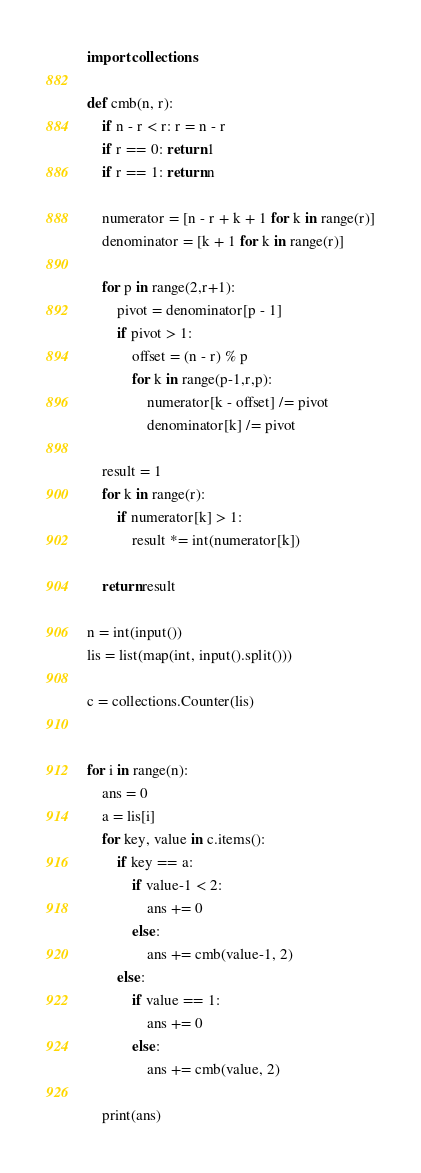Convert code to text. <code><loc_0><loc_0><loc_500><loc_500><_Python_>import collections

def cmb(n, r):
    if n - r < r: r = n - r
    if r == 0: return 1
    if r == 1: return n

    numerator = [n - r + k + 1 for k in range(r)]
    denominator = [k + 1 for k in range(r)]

    for p in range(2,r+1):
        pivot = denominator[p - 1]
        if pivot > 1:
            offset = (n - r) % p
            for k in range(p-1,r,p):
                numerator[k - offset] /= pivot
                denominator[k] /= pivot

    result = 1
    for k in range(r):
        if numerator[k] > 1:
            result *= int(numerator[k])

    return result

n = int(input())
lis = list(map(int, input().split()))

c = collections.Counter(lis)


for i in range(n):
    ans = 0
    a = lis[i]
    for key, value in c.items():
        if key == a:
            if value-1 < 2:
                ans += 0
            else:
                ans += cmb(value-1, 2)
        else:
            if value == 1:
                ans += 0
            else:
                ans += cmb(value, 2)
    
    print(ans)</code> 